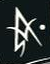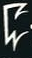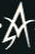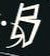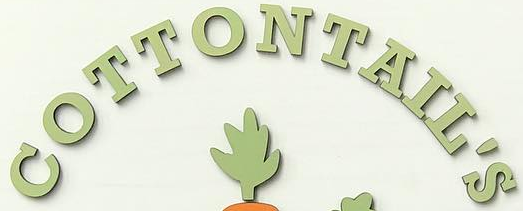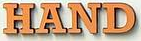Read the text content from these images in order, separated by a semicolon. A; C; A; B; COTTONTAIL'S; HAND 